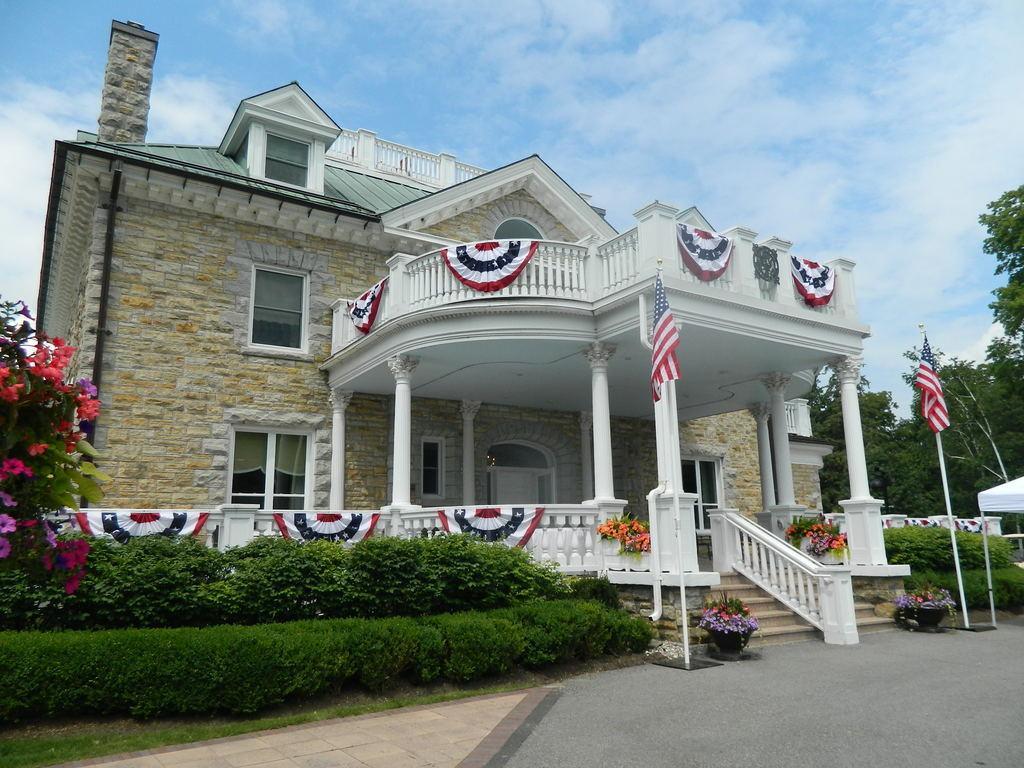Could you give a brief overview of what you see in this image? In this image I can see a road in the front. I can also see few flowers, two poles and two flags on it. In the centre of the image I can see a building and on the right side I can see number of trees. In the background I can see clouds and the sky. I can also see number of clothes on the building. 